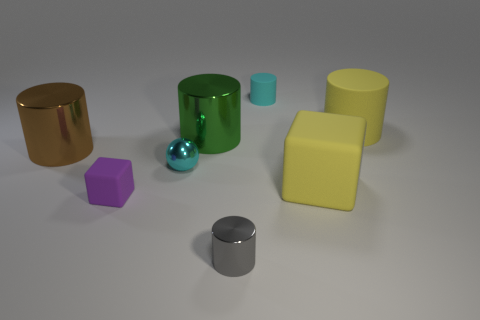Subtract all big yellow cylinders. How many cylinders are left? 4 Add 2 tiny cyan metallic spheres. How many objects exist? 10 Subtract all green cylinders. How many cylinders are left? 4 Subtract all spheres. How many objects are left? 7 Subtract all yellow cylinders. Subtract all blue spheres. How many cylinders are left? 4 Add 2 metallic spheres. How many metallic spheres exist? 3 Subtract 0 gray spheres. How many objects are left? 8 Subtract all green cylinders. Subtract all large brown metallic objects. How many objects are left? 6 Add 2 cyan metal balls. How many cyan metal balls are left? 3 